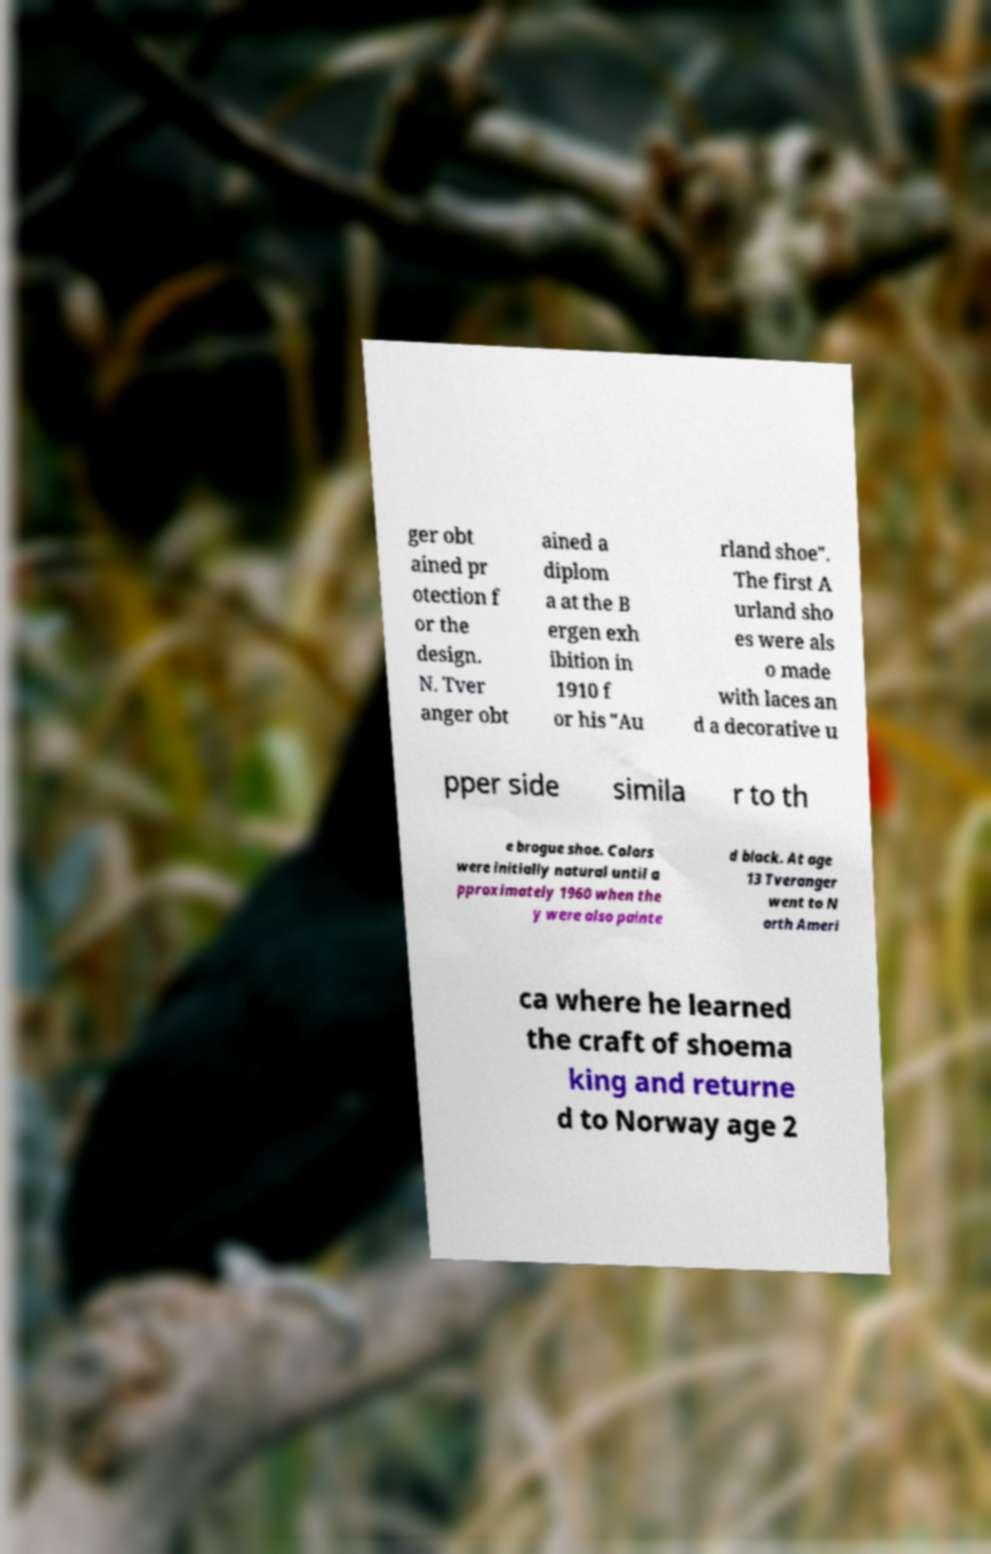Can you accurately transcribe the text from the provided image for me? ger obt ained pr otection f or the design. N. Tver anger obt ained a diplom a at the B ergen exh ibition in 1910 f or his "Au rland shoe". The first A urland sho es were als o made with laces an d a decorative u pper side simila r to th e brogue shoe. Colors were initially natural until a pproximately 1960 when the y were also painte d black. At age 13 Tveranger went to N orth Ameri ca where he learned the craft of shoema king and returne d to Norway age 2 